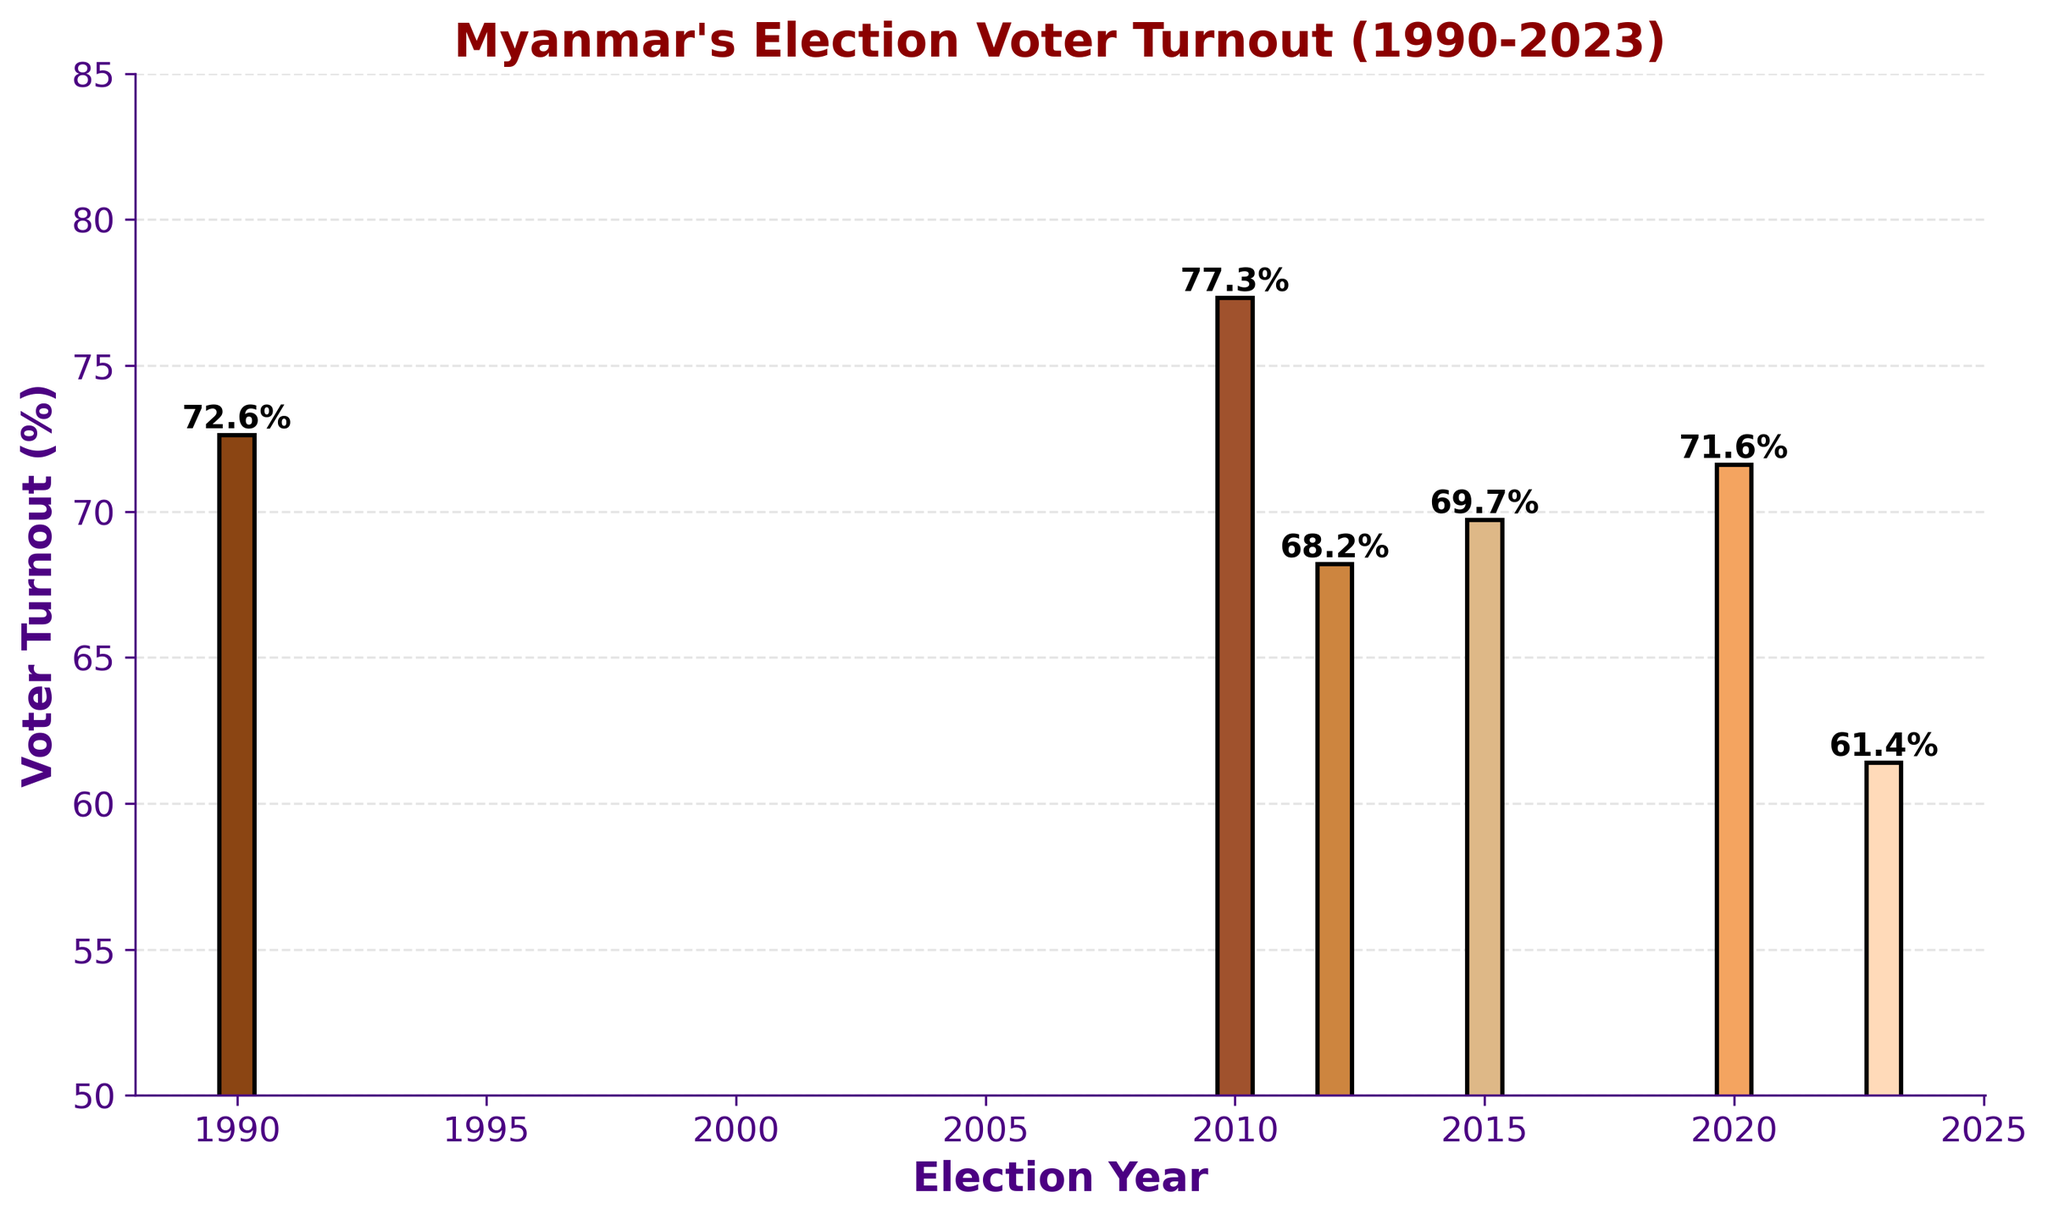What was the highest voter turnout recorded in Myanmar's elections since 1990? By looking at the bar heights in the chart, 2010 appears to have the highest bar representing voter turnout. The value here is 77.3%.
Answer: 77.3% Which election year had the lowest voter turnout and what was the percentage? By observing the bar chart, the shortest bar represents the lowest voter turnout, which corresponds to the year 2023 with a value of 61.4%.
Answer: 2023, 61.4% How did the voter turnout in 2020 compare to that of 2010? Comparing the bars for the years 2020 and 2010, the bar for 2010 is taller, indicating a higher voter turnout in 2010 (77.3%) compared to 2020 (71.6%).
Answer: 2010 was higher by 5.7% What's the average voter turnout from 1990 to 2023? First sum all the percentages: 72.6 + 77.3 + 68.2 + 69.7 + 71.6 + 61.4 = 420.8. Then divide by the number of years (6): 420.8 / 6 = 70.1.
Answer: 70.1% What is the difference in voter turnout between 2015 and 2023? Subtract the turnout of 2023 from that of 2015: 69.7 - 61.4 = 8.3.
Answer: 8.3% Which election years had voter turnouts higher than 70%? By inspecting the bars, the years with voter turnouts higher than 70% are 1990, 2010, and 2020.
Answer: 1990, 2010, 2020 What is the median voter turnout from the election years listed? Arrange the turnouts in ascending order: 61.4, 68.2, 69.7, 71.6, 72.6, 77.3. The middle values are 69.7 and 71.6. Median is (69.7 + 71.6) / 2 = 70.65.
Answer: 70.65 Compare the voter turnout between 1990 and 2015. Which was higher and by how much? The voter turnout in 1990 was 72.6% and in 2015 was 69.7%. The difference is 72.6 - 69.7 = 2.9%.
Answer: 1990 was higher by 2.9% Between which consecutive election years did the voter turnout drop the most? By calculating the differences: 
1990 to 2010: 77.3 - 72.6 = 4.7 
2010 to 2012: 77.3 - 68.2 = 9.1 
2012 to 2015: 69.7 - 68.2 = 1.5 
2015 to 2020: 71.6 - 69.7 = 1.9 
2020 to 2023: 71.6 - 61.4 = 10.2 
The largest drop is from 2020 to 2023, which is 10.2%.
Answer: 2020 to 2023, by 10.2% 